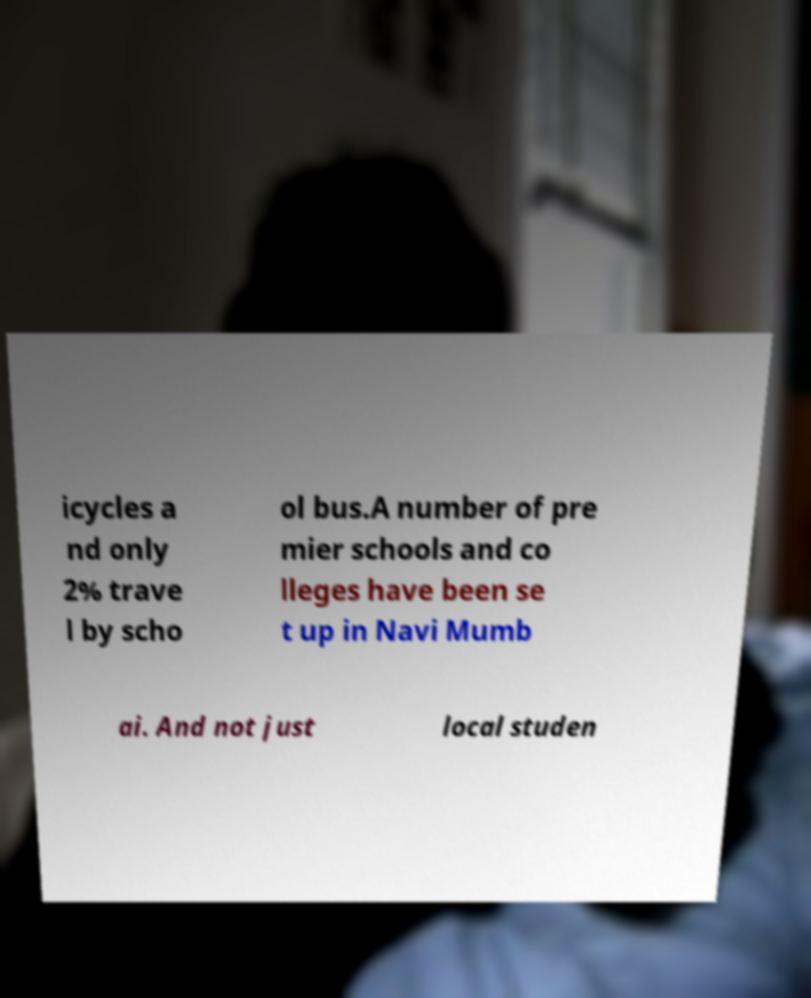Please read and relay the text visible in this image. What does it say? icycles a nd only 2% trave l by scho ol bus.A number of pre mier schools and co lleges have been se t up in Navi Mumb ai. And not just local studen 